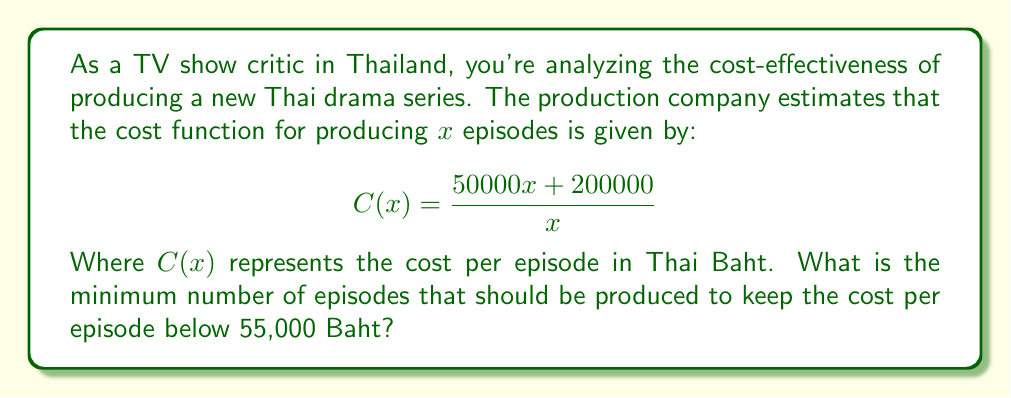Can you answer this question? Let's approach this step-by-step:

1) We want to find x such that C(x) < 55000

2) Substitute this into our inequality:

   $$\frac{50000x + 200000}{x} < 55000$$

3) Multiply both sides by x:

   $$50000x + 200000 < 55000x$$

4) Subtract 50000x from both sides:

   $$200000 < 5000x$$

5) Divide both sides by 5000:

   $$40 < x$$

6) Since x represents the number of episodes, it must be a whole number. Therefore, the minimum number of episodes is the smallest integer greater than 40.
Answer: 41 episodes 